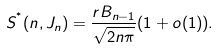<formula> <loc_0><loc_0><loc_500><loc_500>S ^ { ^ { * } } ( n , J _ { n } ) = \frac { r B _ { n - 1 } } { \sqrt { 2 n \pi } } ( 1 + o ( 1 ) ) .</formula> 